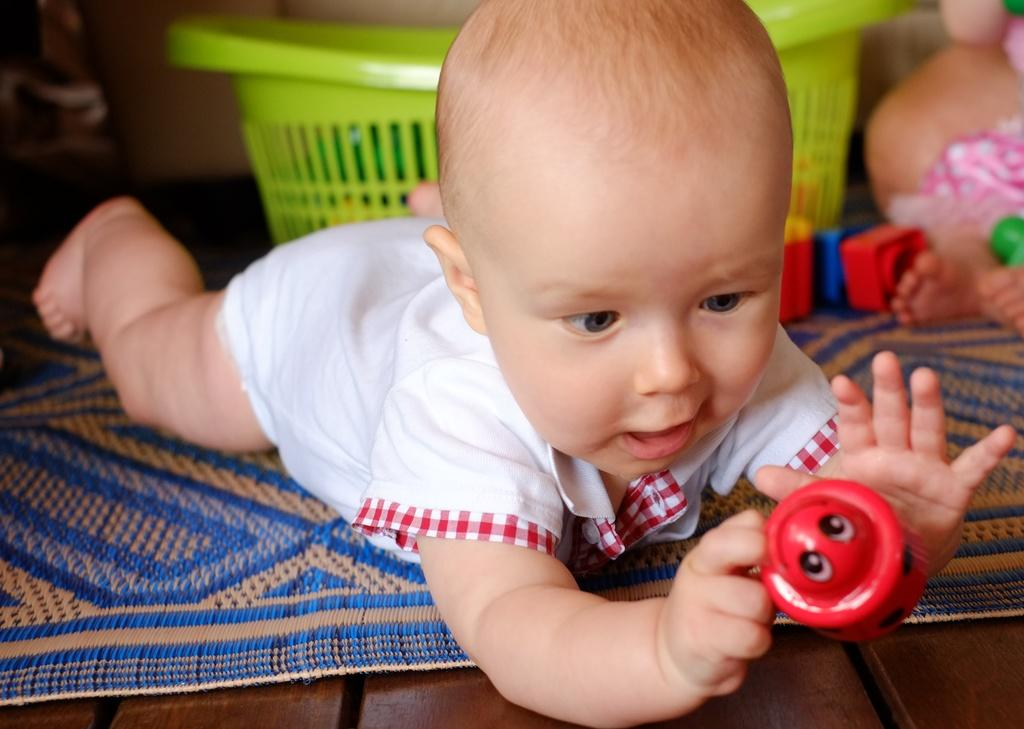What is the main subject of the image? There is a baby in the middle of the image. What is the baby doing in the image? The baby is lying down and playing with a toy. What can be seen behind the baby? There is a basket behind the baby. Are there any other toys visible in the image? Yes, there are additional toys near the baby. What type of payment is being discussed in the meeting shown in the image? There is no meeting or payment being discussed in the image; it features a baby playing with toys. What type of cushion is the baby sitting on in the image? The baby is lying down, not sitting, and there is no cushion mentioned or visible in the image. 